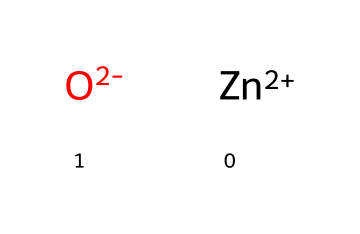What is the central atom in this chemical structure? The chemical structure includes a zinc ion depicted as [Zn+2], which functions as the central atom in this composition.
Answer: zinc How many oxygen atoms are there in this compound? The structure [O-2] indicates the presence of one oxygen atom. Therefore, there is one oxygen atom within the chemical composition.
Answer: one What type of ion is represented by [Zn+2]? The notation [Zn+2] signifies that this is a zinc ion with a +2 charge, indicating a cationic form of zinc commonly used in various applications, including cosmetics.
Answer: cation What is the charge of the oxygen atom in this structure? The structure shows [O-2], which indicates that the oxygen atom carries a -2 charge, signifying it as an anion.
Answer: -2 How does this chemical compound contribute to sunscreen formulation? Zinc ion (Zn) is known for its UV filtering capabilities, which help protect the skin from harmful ultraviolet rays. This makes it a common ingredient in eco-friendly sunscreens.
Answer: UV filtering What kind of bond is likely between zinc and oxygen in this structure? Given the charges of zinc (+2) and oxygen (-2), it suggests an ionic bond, where the zinc cation is attracted to the oxygen anion, typically seen in compounds used for biological applications.
Answer: ionic bond 